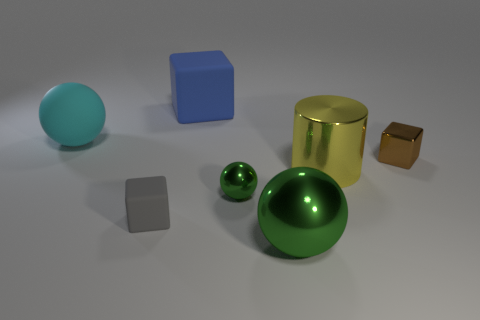Are there the same number of cubes in front of the big blue thing and blue objects left of the small matte block?
Provide a succinct answer. No. Does the tiny gray block have the same material as the tiny brown cube?
Keep it short and to the point. No. There is a big ball behind the tiny brown block; are there any blue things that are to the right of it?
Ensure brevity in your answer.  Yes. Are there any large blue objects that have the same shape as the brown object?
Give a very brief answer. Yes. Is the small shiny sphere the same color as the large metallic sphere?
Keep it short and to the point. Yes. There is a blue thing behind the cube in front of the small brown metallic cube; what is it made of?
Provide a short and direct response. Rubber. The blue thing is what size?
Offer a very short reply. Large. There is a block that is made of the same material as the big green ball; what size is it?
Give a very brief answer. Small. Do the rubber thing that is behind the cyan sphere and the big cylinder have the same size?
Your response must be concise. Yes. The tiny thing that is behind the yellow shiny thing that is behind the green shiny thing that is behind the large green ball is what shape?
Provide a succinct answer. Cube. 